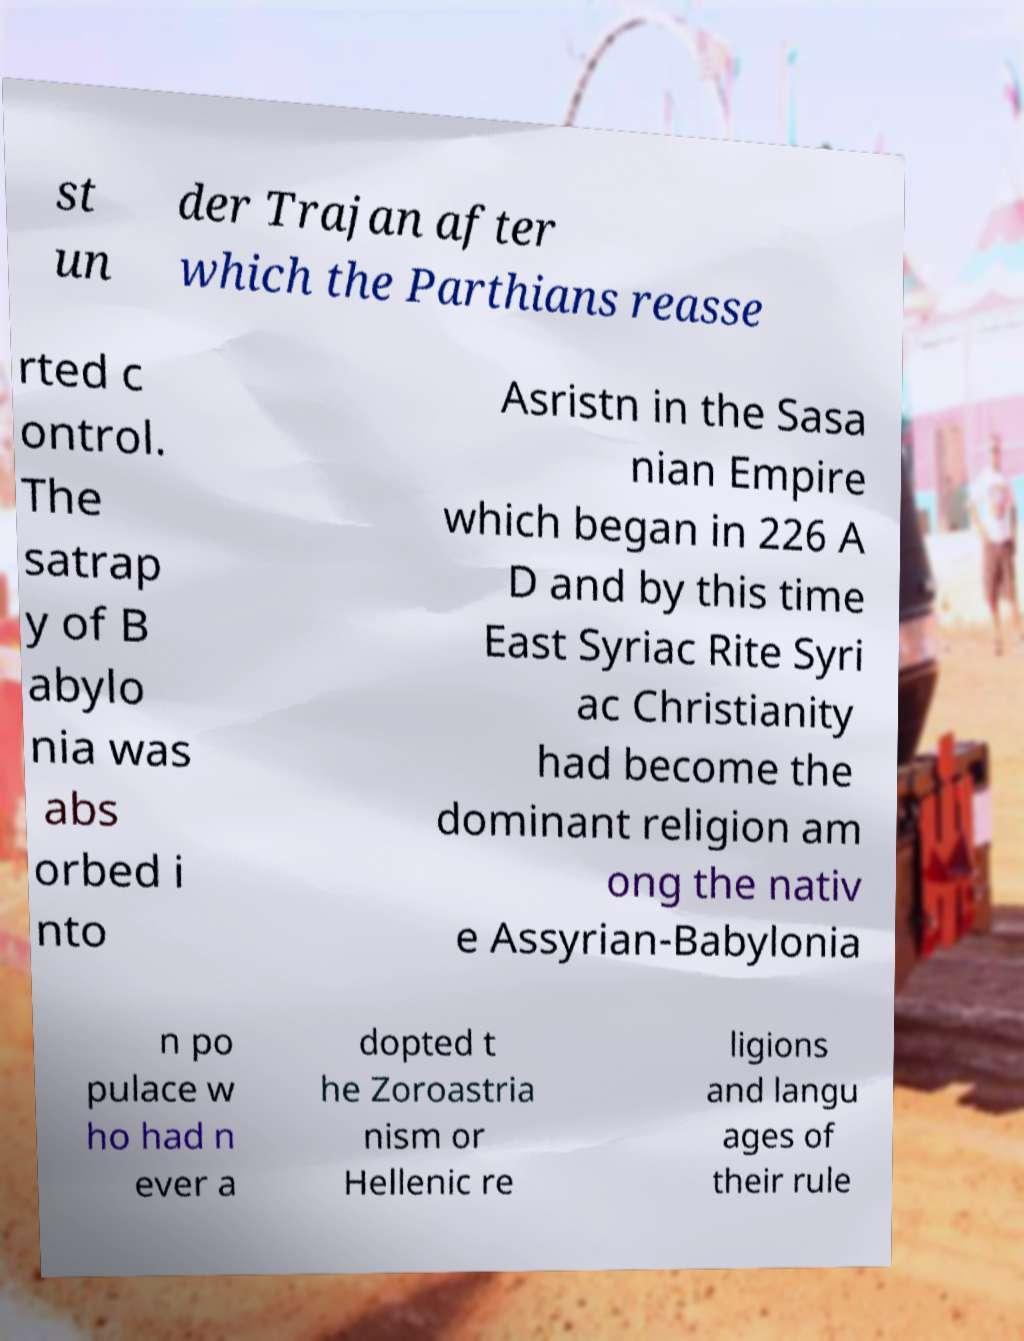There's text embedded in this image that I need extracted. Can you transcribe it verbatim? st un der Trajan after which the Parthians reasse rted c ontrol. The satrap y of B abylo nia was abs orbed i nto Asristn in the Sasa nian Empire which began in 226 A D and by this time East Syriac Rite Syri ac Christianity had become the dominant religion am ong the nativ e Assyrian-Babylonia n po pulace w ho had n ever a dopted t he Zoroastria nism or Hellenic re ligions and langu ages of their rule 